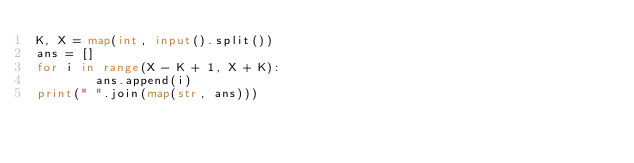Convert code to text. <code><loc_0><loc_0><loc_500><loc_500><_Python_>K, X = map(int, input().split())
ans = []
for i in range(X - K + 1, X + K):
        ans.append(i)
print(" ".join(map(str, ans)))
</code> 